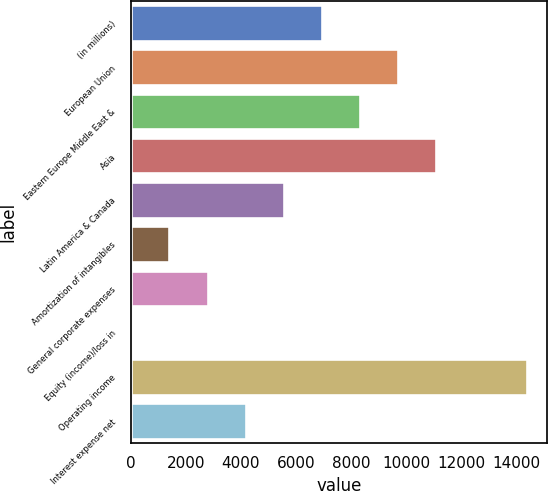<chart> <loc_0><loc_0><loc_500><loc_500><bar_chart><fcel>(in millions)<fcel>European Union<fcel>Eastern Europe Middle East &<fcel>Asia<fcel>Latin America & Canada<fcel>Amortization of intangibles<fcel>General corporate expenses<fcel>Equity (income)/loss in<fcel>Operating income<fcel>Interest expense net<nl><fcel>6940<fcel>9709.2<fcel>8324.6<fcel>11093.8<fcel>5555.4<fcel>1401.6<fcel>2786.2<fcel>17<fcel>14388.6<fcel>4170.8<nl></chart> 